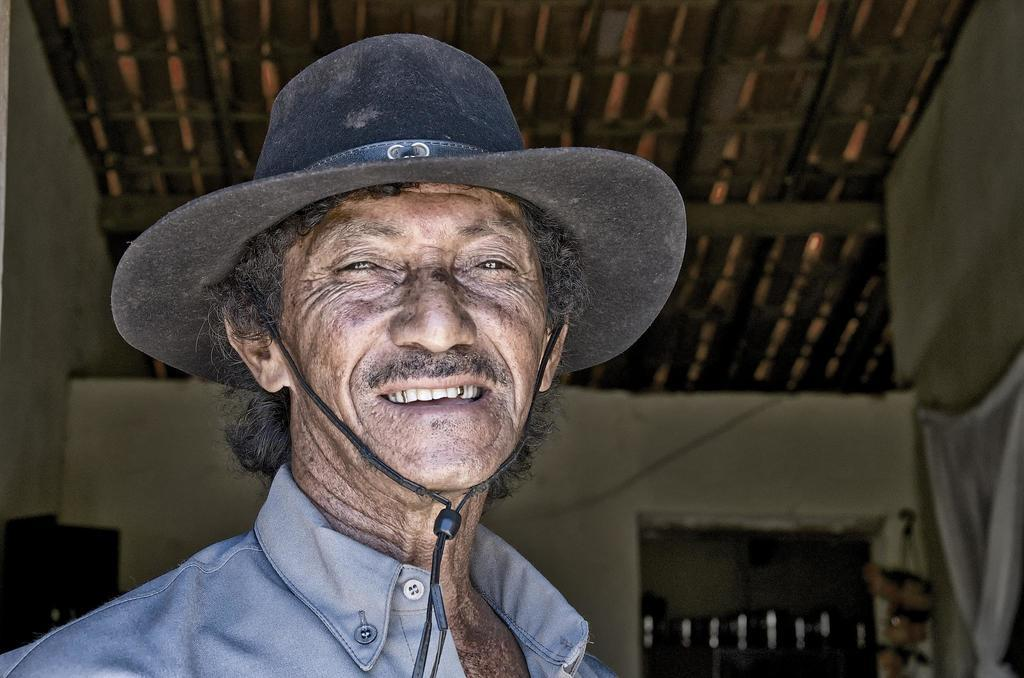What is the main subject of the image? The main subject of the image is a man. What is the man wearing on his head? The man is wearing a black hat. What color is the shirt the man is wearing? The man is wearing a blue shirt. What can be seen in the background of the image? There is a wall in the background of the image. What type of bike is the man riding in the image? There is no bike present in the image; the man is standing still. What cause does the man represent in the image? The image does not indicate any specific cause or affiliation. 